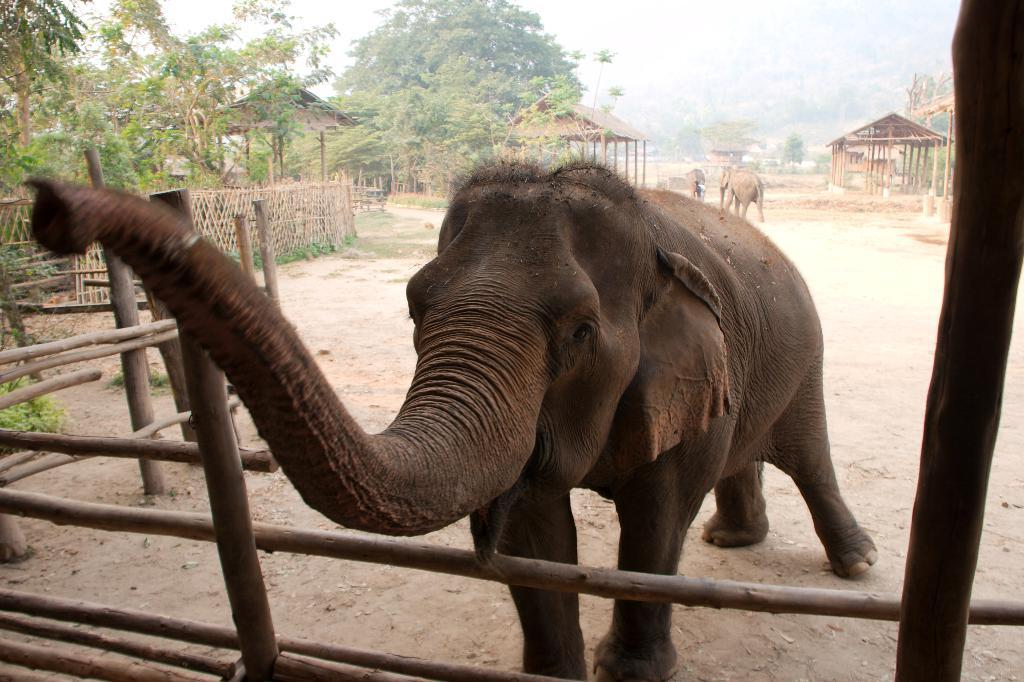What animal is the main subject of the image? There is an elephant in the image. What can be seen in the background of the image? There are trees, wooden shelters, and fencing in the background of the image. What type of boundary is present at the bottom of the image? There is a bamboo boundary at the bottom of the image. How many elbows does the elephant have in the image? Elephants do not have elbows; they have front legs and hind legs. --- Facts: 1. There is a person holding a camera in the image. 2. The person is standing on a bridge. 3. There is a river below the bridge. 4. There are boats on the river. 5. The sky is visible in the image. Absurd Topics: parrot, sandcastle, laughter Conversation: What is the person in the image doing? The person in the image is holding a camera. Where is the person standing in the image? The person is standing on a bridge. What can be seen below the bridge in the image? There is a river below the bridge, and boats are on the river. What is visible in the sky in the image? The sky is visible in the image. Reasoning: Let's think step by step in order to produce the conversation. We start by identifying the main subject of the image, which is the person holding a camera. Then, we expand the conversation to include other elements in the image, such as the bridge, the river, the boats, and the sky. Each question is designed to elicit a specific detail about the image that is known from the provided facts. Absurd Question/Answer: Can you hear the laughter of the parrot in the image? There is no parrot or laughter present in the image. 